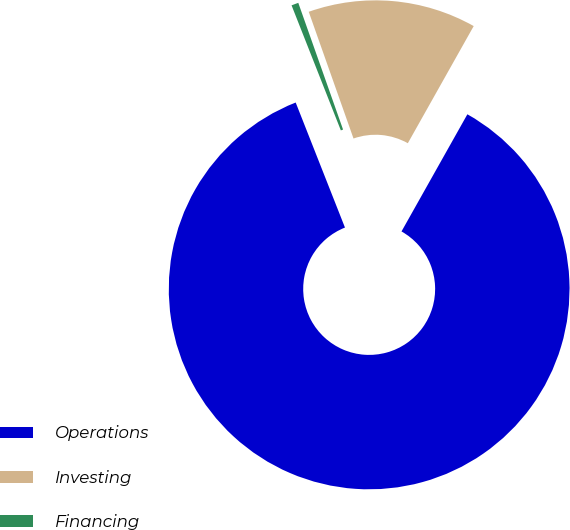<chart> <loc_0><loc_0><loc_500><loc_500><pie_chart><fcel>Operations<fcel>Investing<fcel>Financing<nl><fcel>85.87%<fcel>13.56%<fcel>0.57%<nl></chart> 